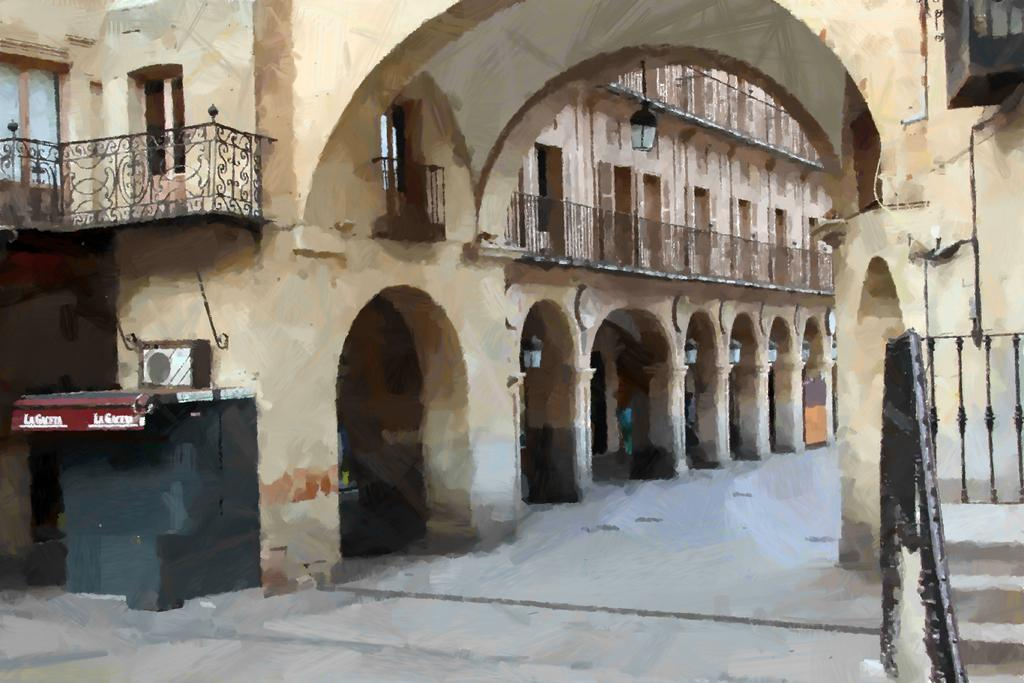What type of structure is visible in the image? There is a building in the image. What feature can be seen on the building? The building has windows. What is located in front of the building? There is a railing in the front of the building. What is at the bottom of the image? There is a road at the bottom of the image. Where are the steps located in the image? The steps are on the right side of the image. What color is the scarf that the building is wearing in the image? There is no scarf present in the image, as buildings do not wear scarves. 